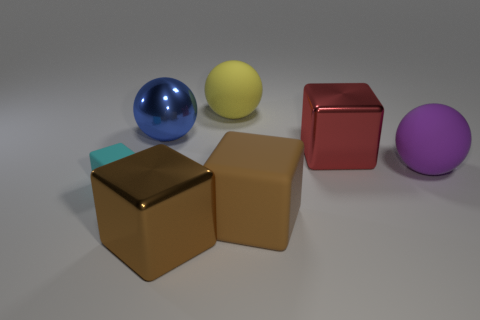There is a blue shiny sphere; is its size the same as the cube that is on the left side of the blue sphere?
Provide a succinct answer. No. What is the color of the rubber block that is the same size as the purple rubber sphere?
Ensure brevity in your answer.  Brown. What size is the red block?
Your response must be concise. Large. Is the material of the large yellow sphere to the right of the brown shiny cube the same as the purple object?
Your answer should be very brief. Yes. Does the blue thing have the same shape as the big red object?
Ensure brevity in your answer.  No. There is a rubber object that is behind the large rubber ball in front of the matte thing behind the blue shiny thing; what shape is it?
Ensure brevity in your answer.  Sphere. There is a rubber thing that is left of the large brown shiny object; is it the same shape as the matte object behind the big purple rubber object?
Your response must be concise. No. Are there any yellow spheres made of the same material as the small cube?
Ensure brevity in your answer.  Yes. What is the color of the rubber cube that is on the right side of the matte thing to the left of the large brown metal cube in front of the large purple thing?
Offer a terse response. Brown. Is the cube that is behind the cyan cube made of the same material as the large blue ball that is behind the big purple object?
Provide a succinct answer. Yes. 